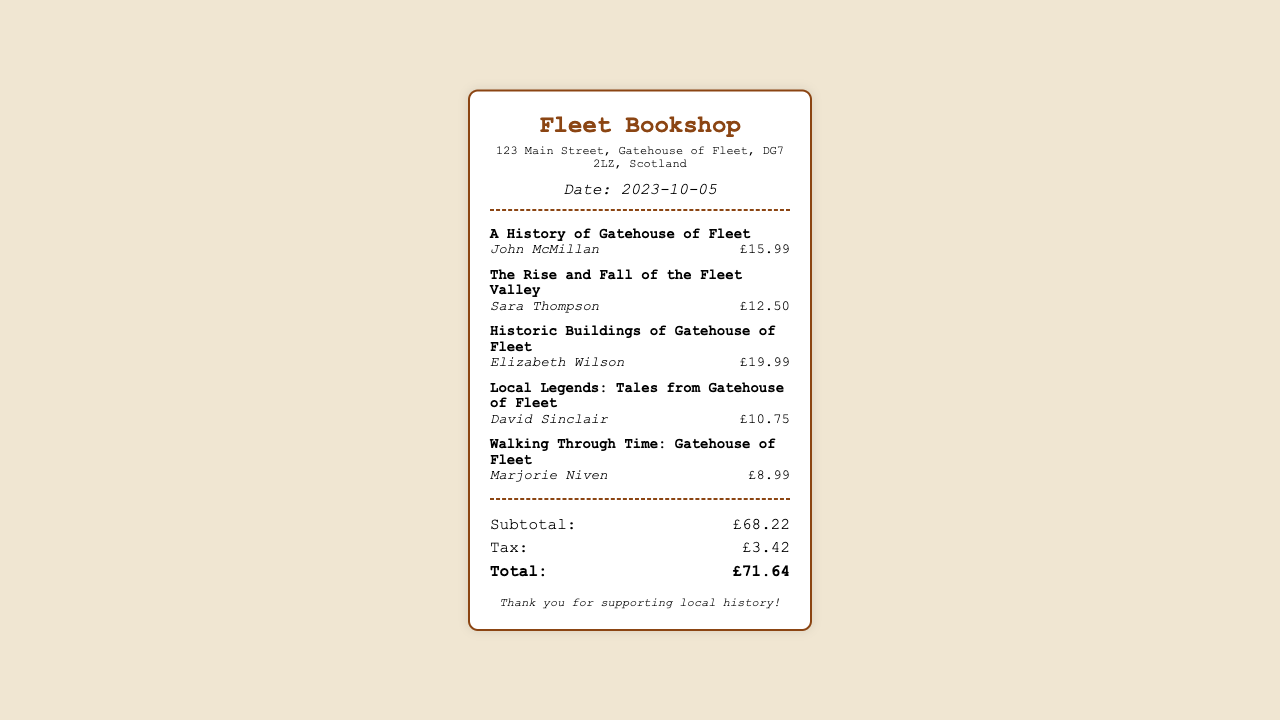What is the date of the receipt? The date is noted in the document under the header section.
Answer: 2023-10-05 Who is the author of "A History of Gatehouse of Fleet"? The author is mentioned right below the book title in the item details.
Answer: John McMillan What is the price of "Walking Through Time: Gatehouse of Fleet"? The price is shown alongside the book title and author in the item section.
Answer: £8.99 What are the total tax charges listed on the receipt? The total tax charges are highlighted in the totals section of the receipt.
Answer: £3.42 How many books are purchased in total? By counting the items listed in the receipt, we can determine the total number of books.
Answer: 5 What is the subtotal before tax? The subtotal is provided in the totals section before the tax charges are added.
Answer: £68.22 Which book has the highest price? By comparing the prices listed for all the books, we find the highest priced book.
Answer: Historic Buildings of Gatehouse of Fleet What is the total amount paid after tax? The total amount is displayed at the end of the totals section.
Answer: £71.64 Which bookstore issued this receipt? The name of the bookstore is shown at the top of the receipt.
Answer: Fleet Bookshop 